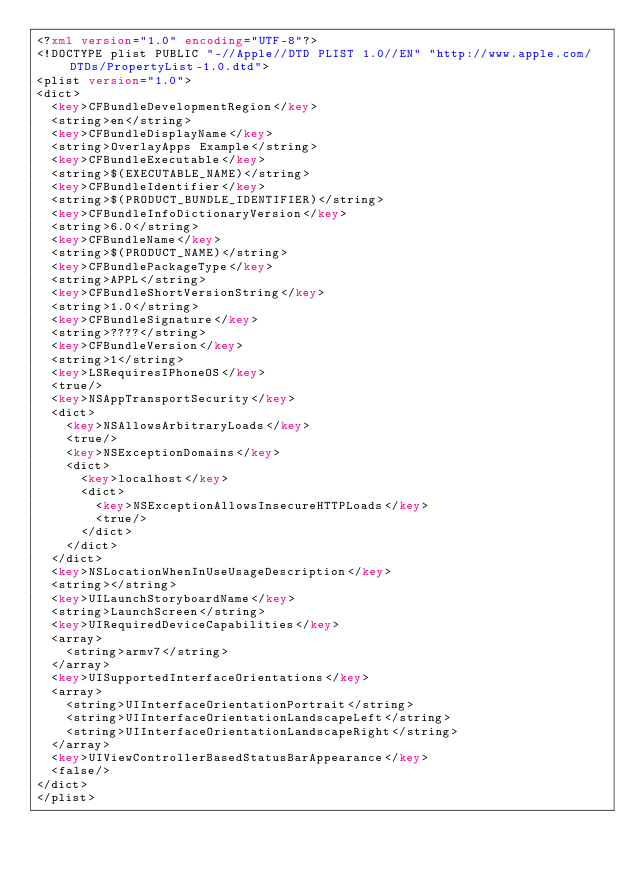<code> <loc_0><loc_0><loc_500><loc_500><_XML_><?xml version="1.0" encoding="UTF-8"?>
<!DOCTYPE plist PUBLIC "-//Apple//DTD PLIST 1.0//EN" "http://www.apple.com/DTDs/PropertyList-1.0.dtd">
<plist version="1.0">
<dict>
	<key>CFBundleDevelopmentRegion</key>
	<string>en</string>
	<key>CFBundleDisplayName</key>
	<string>OverlayApps Example</string>
	<key>CFBundleExecutable</key>
	<string>$(EXECUTABLE_NAME)</string>
	<key>CFBundleIdentifier</key>
	<string>$(PRODUCT_BUNDLE_IDENTIFIER)</string>
	<key>CFBundleInfoDictionaryVersion</key>
	<string>6.0</string>
	<key>CFBundleName</key>
	<string>$(PRODUCT_NAME)</string>
	<key>CFBundlePackageType</key>
	<string>APPL</string>
	<key>CFBundleShortVersionString</key>
	<string>1.0</string>
	<key>CFBundleSignature</key>
	<string>????</string>
	<key>CFBundleVersion</key>
	<string>1</string>
	<key>LSRequiresIPhoneOS</key>
	<true/>
	<key>NSAppTransportSecurity</key>
	<dict>
		<key>NSAllowsArbitraryLoads</key>
		<true/>
		<key>NSExceptionDomains</key>
		<dict>
			<key>localhost</key>
			<dict>
				<key>NSExceptionAllowsInsecureHTTPLoads</key>
				<true/>
			</dict>
		</dict>
	</dict>
	<key>NSLocationWhenInUseUsageDescription</key>
	<string></string>
	<key>UILaunchStoryboardName</key>
	<string>LaunchScreen</string>
	<key>UIRequiredDeviceCapabilities</key>
	<array>
		<string>armv7</string>
	</array>
	<key>UISupportedInterfaceOrientations</key>
	<array>
		<string>UIInterfaceOrientationPortrait</string>
		<string>UIInterfaceOrientationLandscapeLeft</string>
		<string>UIInterfaceOrientationLandscapeRight</string>
	</array>
	<key>UIViewControllerBasedStatusBarAppearance</key>
	<false/>
</dict>
</plist>
</code> 